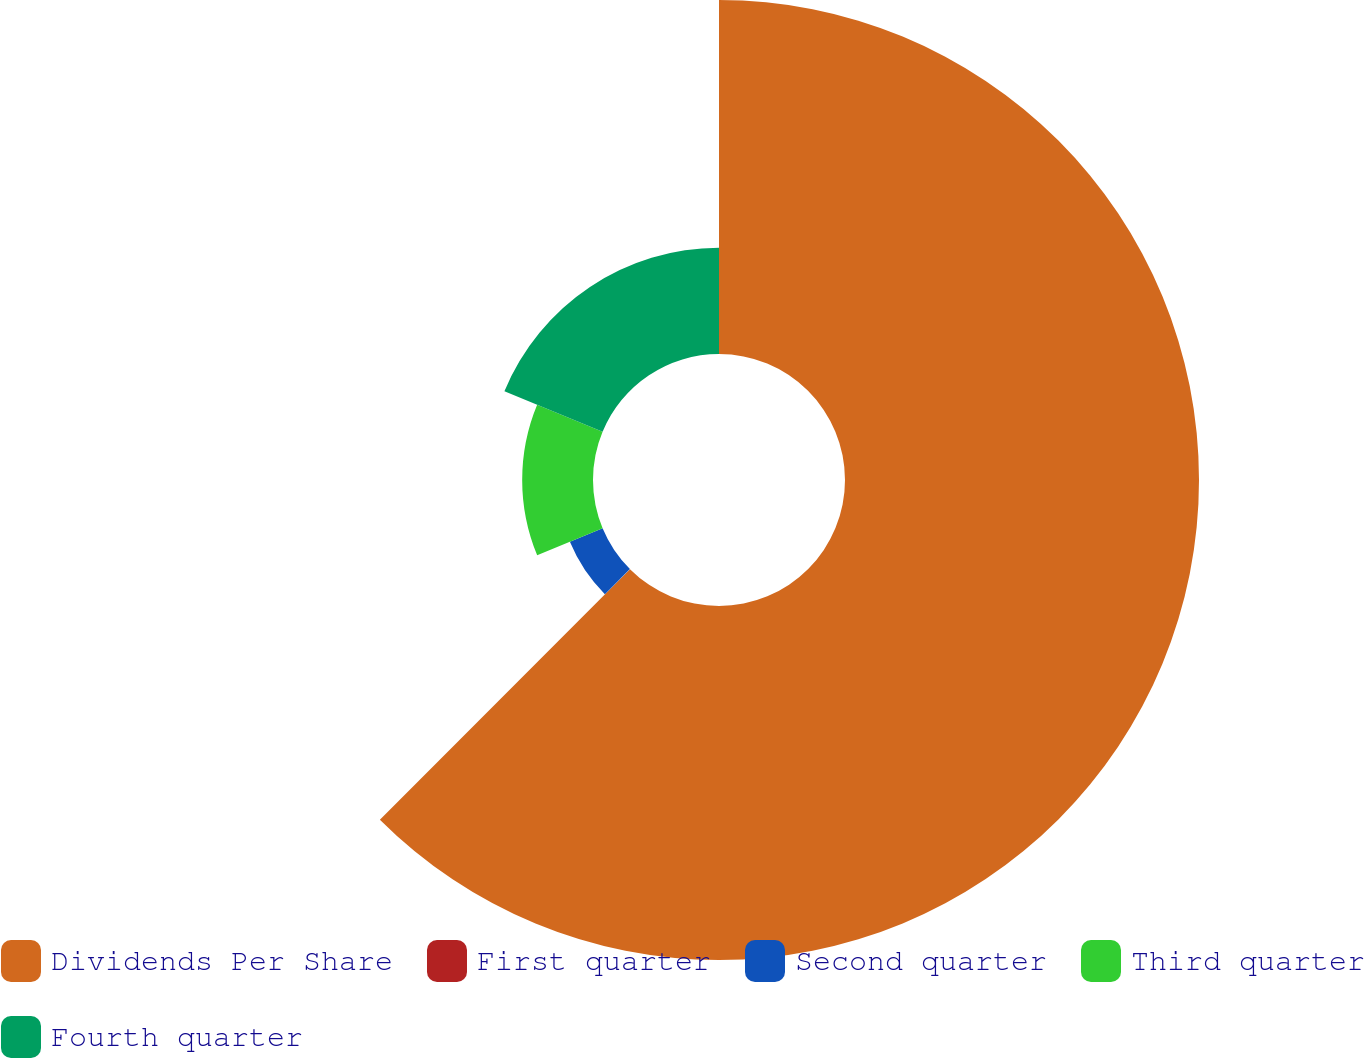<chart> <loc_0><loc_0><loc_500><loc_500><pie_chart><fcel>Dividends Per Share<fcel>First quarter<fcel>Second quarter<fcel>Third quarter<fcel>Fourth quarter<nl><fcel>62.48%<fcel>0.01%<fcel>6.25%<fcel>12.5%<fcel>18.75%<nl></chart> 